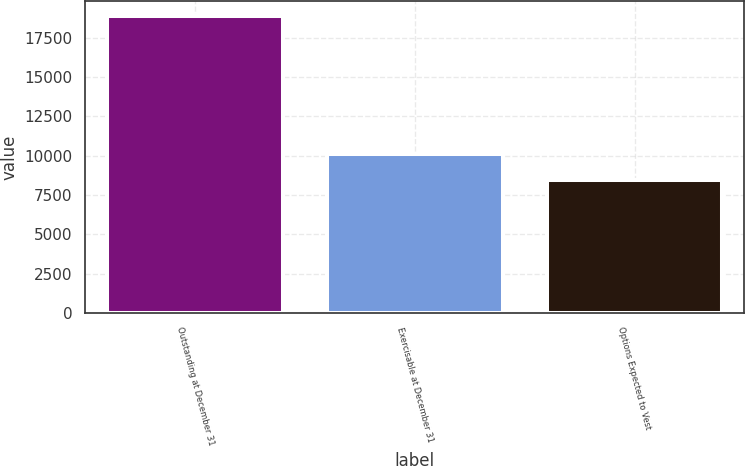<chart> <loc_0><loc_0><loc_500><loc_500><bar_chart><fcel>Outstanding at December 31<fcel>Exercisable at December 31<fcel>Options Expected to Vest<nl><fcel>18882<fcel>10108<fcel>8487<nl></chart> 